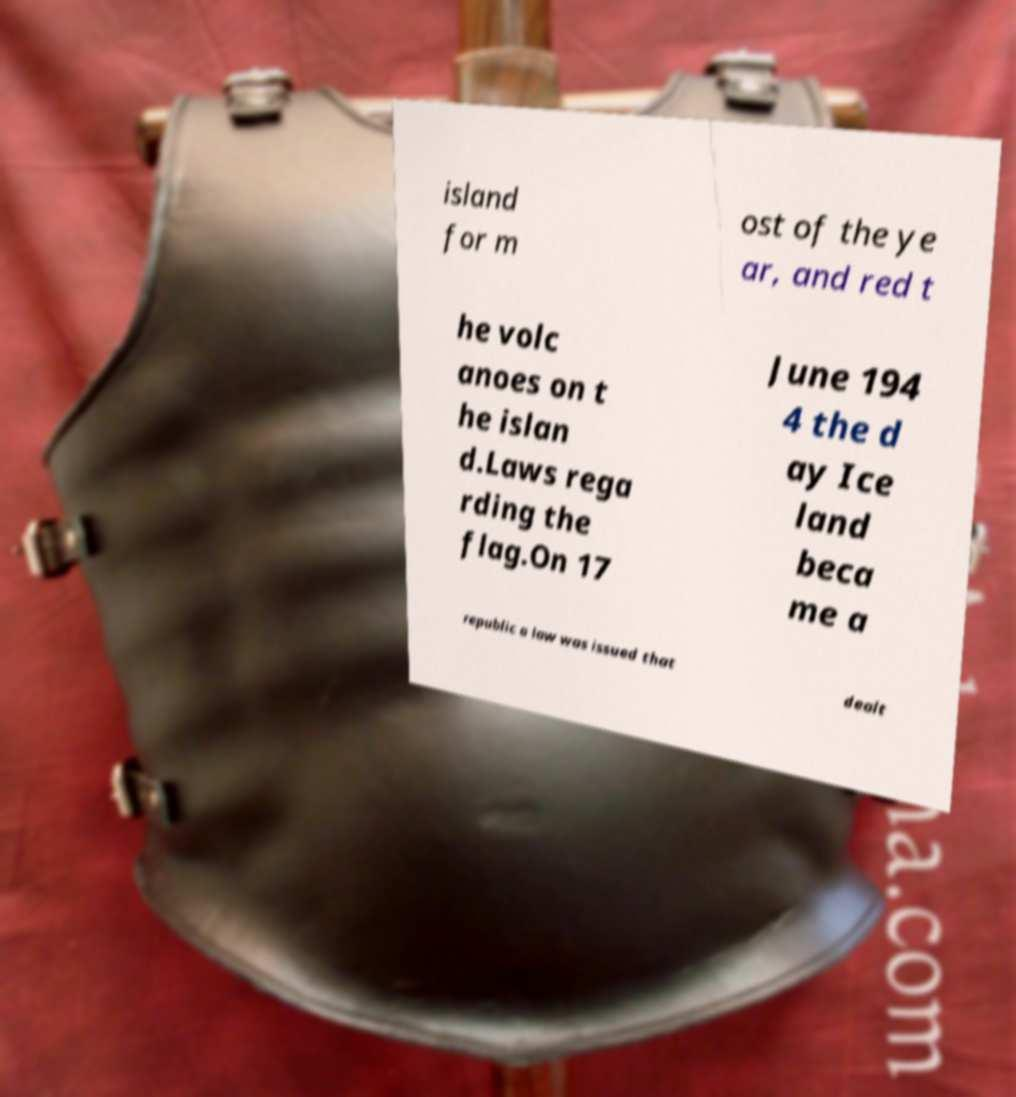Can you accurately transcribe the text from the provided image for me? island for m ost of the ye ar, and red t he volc anoes on t he islan d.Laws rega rding the flag.On 17 June 194 4 the d ay Ice land beca me a republic a law was issued that dealt 